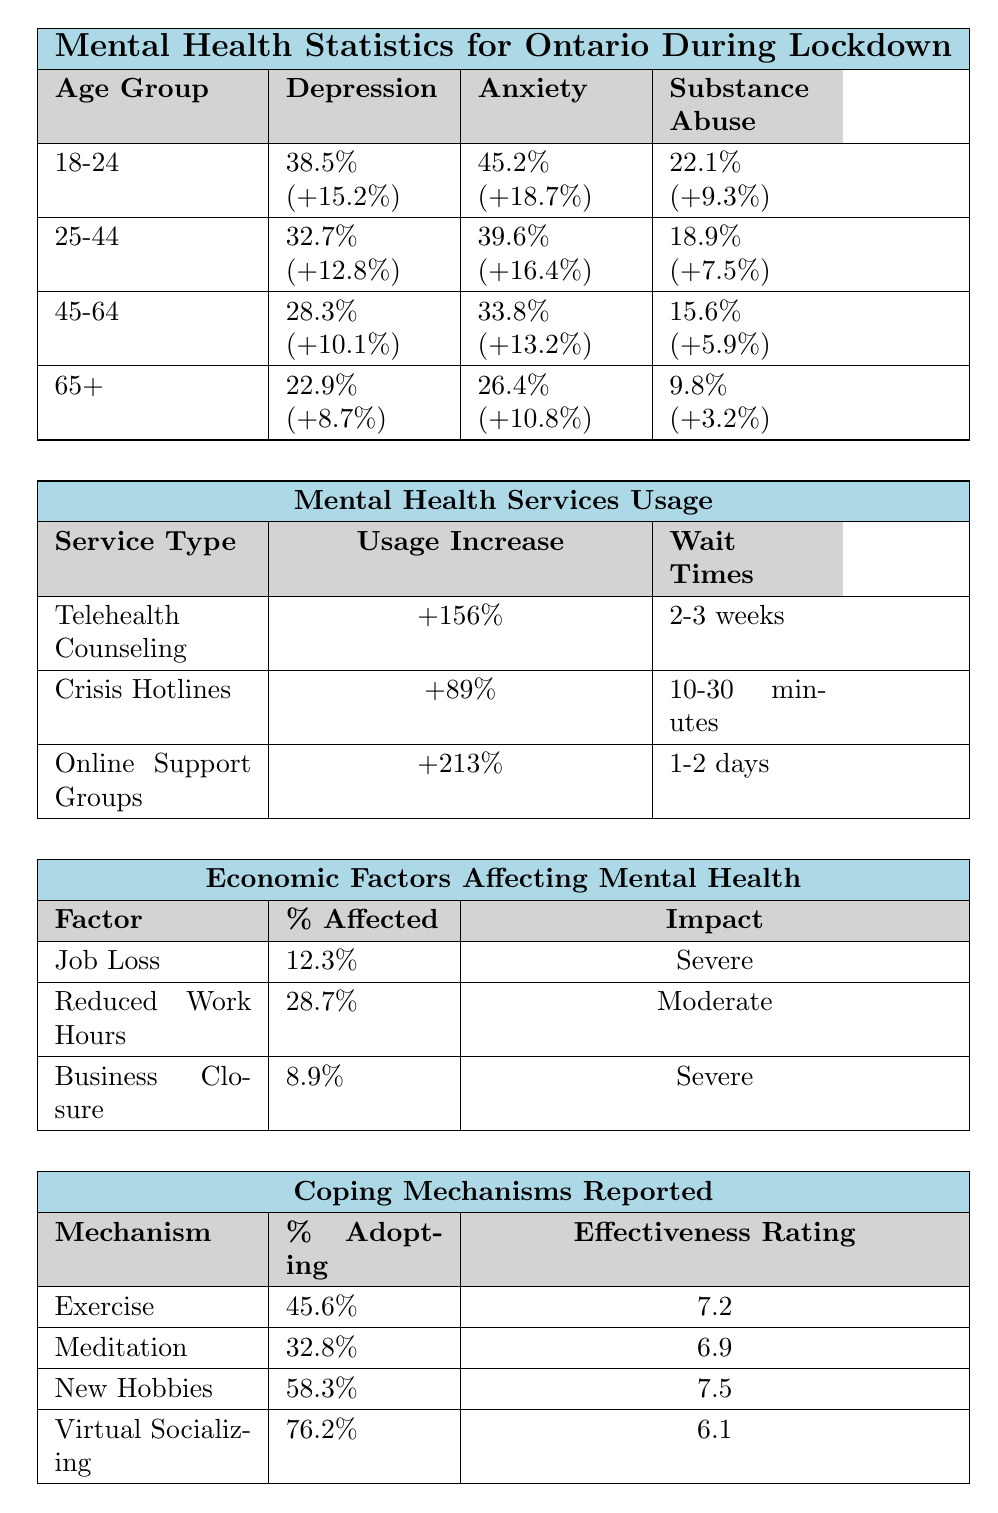What percentage of 18-24 year-olds reported anxiety during lockdown? Referring to the table, the percentage of 18-24 year-olds who reported anxiety is listed as 45.2%.
Answer: 45.2% What was the increase in the usage of online support groups? The table indicates that the usage of online support groups increased by 213%.
Answer: 213% Which age group had the highest reported percentage of depression? By comparing the depression percentages across age groups, 18-24 year-olds had the highest percentage at 38.5%.
Answer: 18-24 What is the average percentage of reported substance abuse across all age groups? To find the average, add the percentages of substance abuse: (22.1 + 18.9 + 15.6 + 9.8) = 66.4%. There are 4 groups, so 66.4% / 4 = 16.6%.
Answer: 16.6% Did the percentage of anxiety among 25-44 year-olds increase by more than 15%? The table shows a percentage of 39.6% for anxiety in this age group with an increase of 16.4%. Since this is greater than 15%, the answer is yes.
Answer: Yes Which coping mechanism was adopted by the highest percentage of residents? The table indicates that virtual socializing, with 76.2% adoption, is the mechanism with the highest percentage of adoption.
Answer: Virtual Socializing What is the total percentage affected by job loss and business closure combined? The table shows job loss affects 12.3% and business closure affects 8.9%. Adding these percentages gives 12.3% + 8.9% = 21.2%.
Answer: 21.2% What is the effectiveness rating of meditation compared to exercise? The effectiveness rating for meditation is 6.9 and for exercise, it is 7.2. Therefore, exercise has a higher rating than meditation.
Answer: Exercise is higher What percentage of individuals reported a severe impact on their mental health due to job loss? The table explicitly states that the impact of job loss on mental health is categorized as 'Severe'.
Answer: 12.3% are affected Is the increase in usage of crisis hotlines greater than that of telehealth counseling? The usage increase for crisis hotlines is 89%, while for telehealth counseling, it is 156%. Since 156% is greater than 89%, the answer is no.
Answer: No 